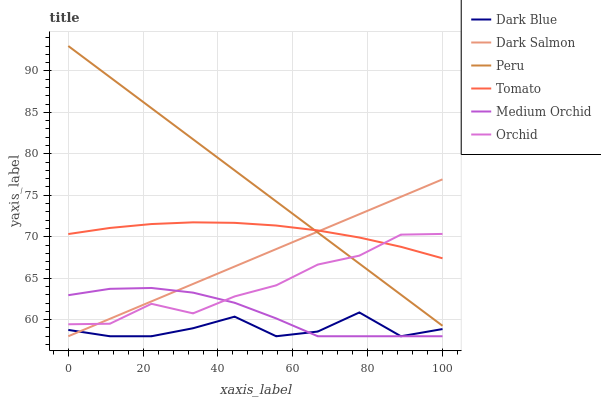Does Dark Blue have the minimum area under the curve?
Answer yes or no. Yes. Does Peru have the maximum area under the curve?
Answer yes or no. Yes. Does Medium Orchid have the minimum area under the curve?
Answer yes or no. No. Does Medium Orchid have the maximum area under the curve?
Answer yes or no. No. Is Dark Salmon the smoothest?
Answer yes or no. Yes. Is Dark Blue the roughest?
Answer yes or no. Yes. Is Medium Orchid the smoothest?
Answer yes or no. No. Is Medium Orchid the roughest?
Answer yes or no. No. Does Peru have the lowest value?
Answer yes or no. No. Does Peru have the highest value?
Answer yes or no. Yes. Does Medium Orchid have the highest value?
Answer yes or no. No. Is Dark Blue less than Tomato?
Answer yes or no. Yes. Is Tomato greater than Dark Blue?
Answer yes or no. Yes. Does Tomato intersect Dark Salmon?
Answer yes or no. Yes. Is Tomato less than Dark Salmon?
Answer yes or no. No. Is Tomato greater than Dark Salmon?
Answer yes or no. No. Does Dark Blue intersect Tomato?
Answer yes or no. No. 